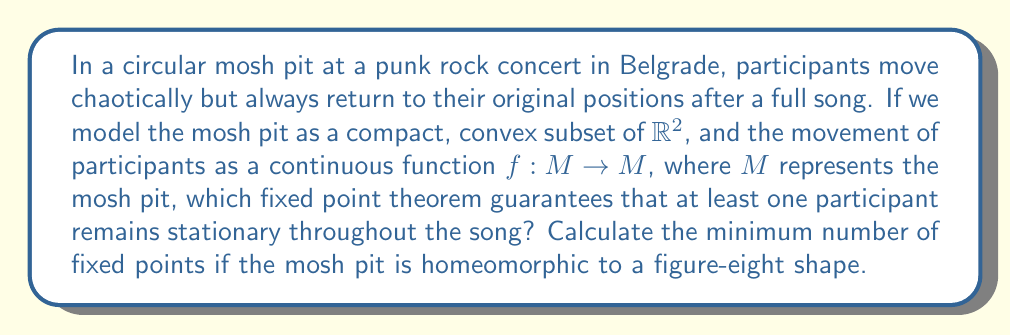Provide a solution to this math problem. To solve this problem, we need to consider two key fixed point theorems:

1. Brouwer's Fixed Point Theorem: This theorem states that for any continuous function $f$ mapping a compact, convex set in Euclidean space to itself, there exists at least one fixed point.

2. The Lefschetz Fixed Point Theorem: This theorem relates the number of fixed points to the Lefschetz number of a continuous map on a compact topological space.

For the circular mosh pit:
The circular mosh pit is a compact, convex subset of $\mathbb{R}^2$. Therefore, Brouwer's Fixed Point Theorem applies, guaranteeing at least one fixed point. This means at least one participant remains stationary throughout the song.

For the figure-eight shaped mosh pit:
The figure-eight shape is not convex, so we cannot apply Brouwer's theorem directly. Instead, we use the Lefschetz Fixed Point Theorem.

The Lefschetz number $L(f)$ for a continuous map $f$ on a figure-eight shape is calculated as follows:

1. The figure-eight has Euler characteristic $\chi = -1$ (it's homotopy equivalent to a wedge of two circles).
2. The identity map on a figure-eight induces the identity map on homology groups.
3. $L(f) = 1 - 2 + 0 = -1$ (alternating sum of traces of induced maps on homology groups).

The Lefschetz Fixed Point Theorem states that if $L(f) \neq 0$, then $f$ has at least one fixed point. Moreover, if all fixed points are isolated, the number of fixed points is at least $|L(f)|$.

Since $|L(f)| = |-1| = 1$, the minimum number of fixed points for the figure-eight shaped mosh pit is 1.
Answer: For the circular mosh pit, Brouwer's Fixed Point Theorem guarantees at least one stationary participant. For the figure-eight shaped mosh pit, the minimum number of fixed points is 1, as determined by the Lefschetz Fixed Point Theorem. 